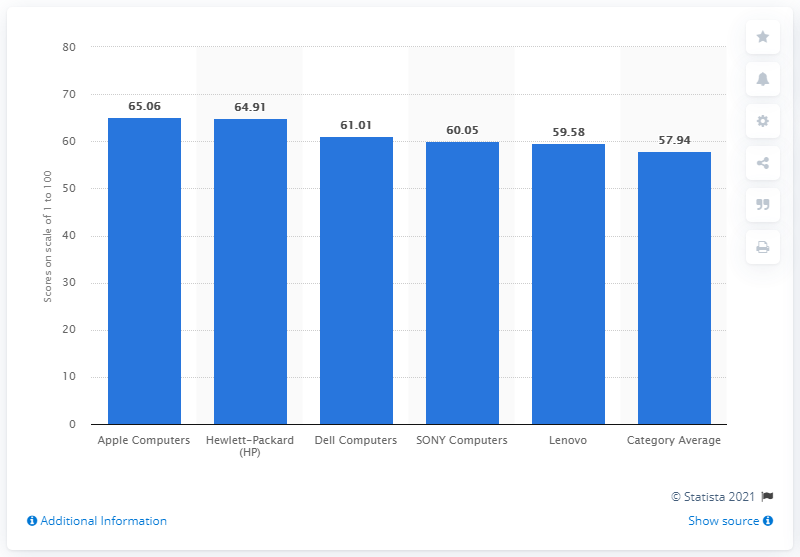Highlight a few significant elements in this photo. Apple Computer received a score of 65.06 out of 100 in a particular evaluation or assessment. 